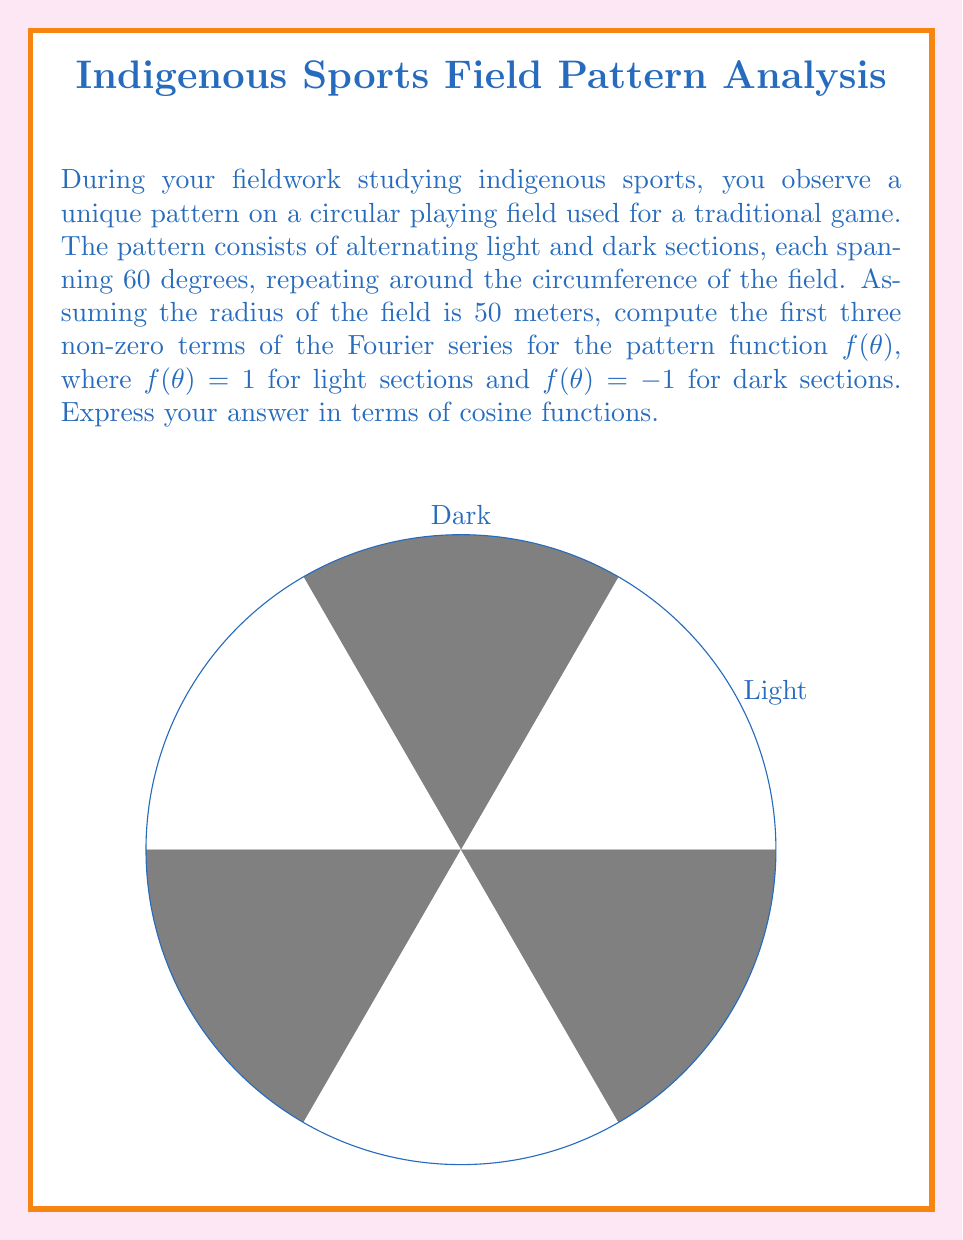Provide a solution to this math problem. Let's approach this step-by-step:

1) The function f(θ) is periodic with period 2π and can be represented as:
   $$f(\theta) = \begin{cases} 
   1, & 0 \leq \theta < \frac{\pi}{3} \\
   -1, & \frac{\pi}{3} \leq \theta < \frac{2\pi}{3} \\
   1, & \frac{2\pi}{3} \leq \theta < \pi \\
   -1, & \pi \leq \theta < \frac{4\pi}{3} \\
   1, & \frac{4\pi}{3} \leq \theta < \frac{5\pi}{3} \\
   -1, & \frac{5\pi}{3} \leq \theta < 2\pi
   \end{cases}$$

2) The general form of the Fourier series for an even function is:
   $$f(\theta) = \frac{a_0}{2} + \sum_{n=1}^{\infty} a_n \cos(n\theta)$$

3) The coefficients are given by:
   $$a_n = \frac{1}{\pi} \int_{0}^{2\pi} f(\theta) \cos(n\theta) d\theta$$

4) For $a_0$:
   $$a_0 = \frac{1}{\pi} \int_{0}^{2\pi} f(\theta) d\theta = 0$$
   (because the positive and negative areas cancel out)

5) For $a_n$ (n > 0):
   $$a_n = \frac{1}{\pi} \left[\int_{0}^{\pi/3} \cos(n\theta) d\theta - \int_{\pi/3}^{2\pi/3} \cos(n\theta) d\theta + \int_{2\pi/3}^{\pi} \cos(n\theta) d\theta - \int_{\pi}^{4\pi/3} \cos(n\theta) d\theta + \int_{4\pi/3}^{5\pi/3} \cos(n\theta) d\theta - \int_{5\pi/3}^{2\pi} \cos(n\theta) d\theta\right]$$

6) Evaluating this integral:
   $$a_n = \frac{4}{n\pi} \left[\sin\left(\frac{n\pi}{3}\right) + \sin\left(\frac{2n\pi}{3}\right) + \sin(n\pi)\right]$$

7) This simplifies to:
   $$a_n = \begin{cases}
   0, & \text{if } n \text{ is not a multiple of 3} \\
   \frac{4}{n\pi}, & \text{if } n \text{ is an odd multiple of 3} \\
   -\frac{4}{n\pi}, & \text{if } n \text{ is an even multiple of 3}
   \end{cases}$$

8) Therefore, the first three non-zero terms are:
   $$\frac{4}{3\pi} \cos(3\theta) - \frac{4}{6\pi} \cos(6\theta) + \frac{4}{9\pi} \cos(9\theta)$$
Answer: $$\frac{4}{3\pi} \cos(3\theta) - \frac{2}{3\pi} \cos(6\theta) + \frac{4}{9\pi} \cos(9\theta)$$ 